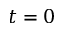<formula> <loc_0><loc_0><loc_500><loc_500>t = 0</formula> 